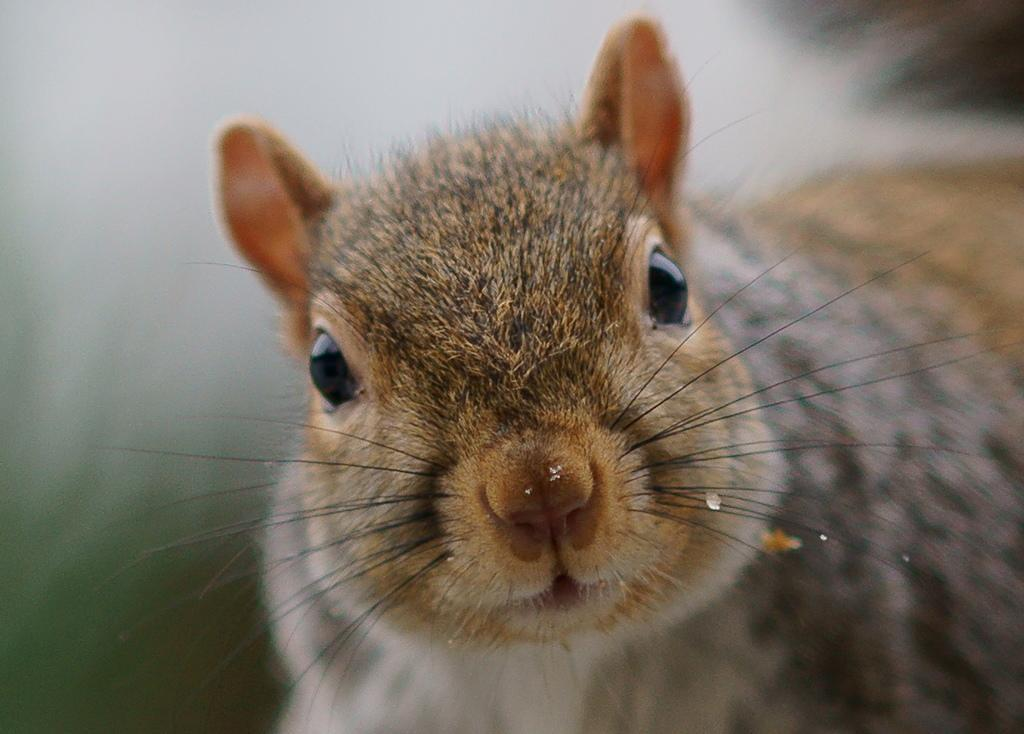What type of living creature is present in the image? There is an animal in the image. Can you describe the background of the image? The background of the image is blurry. What type of clouds can be seen in the image? There are no clouds visible in the image, as the background is blurry and does not show any sky or clouds. 